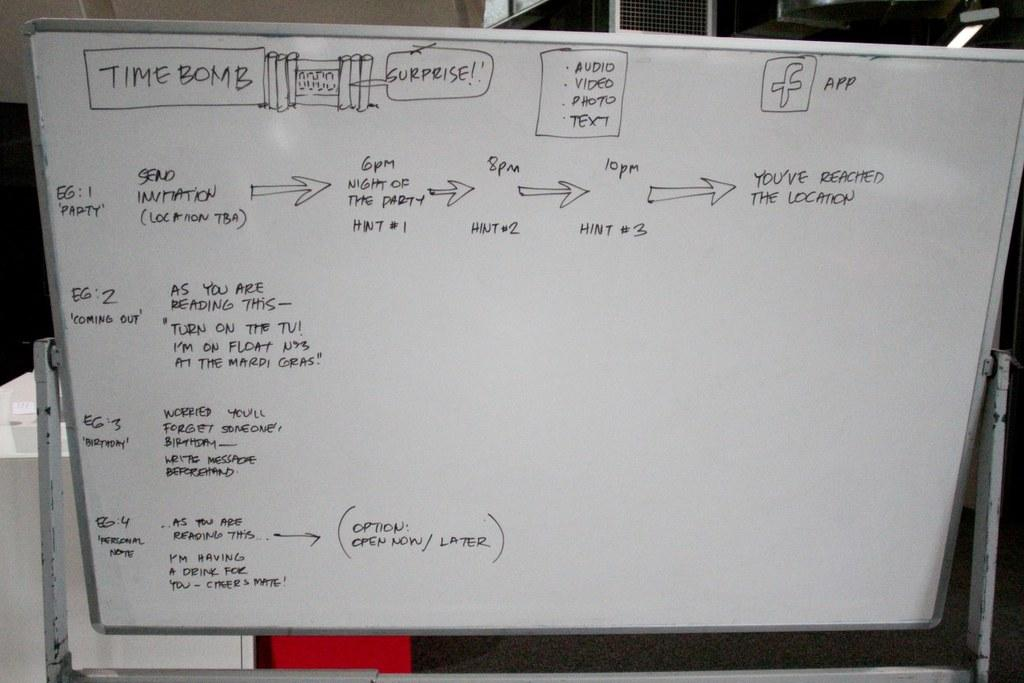<image>
Summarize the visual content of the image. A white board has the words "TIME BOMB" at the top. 